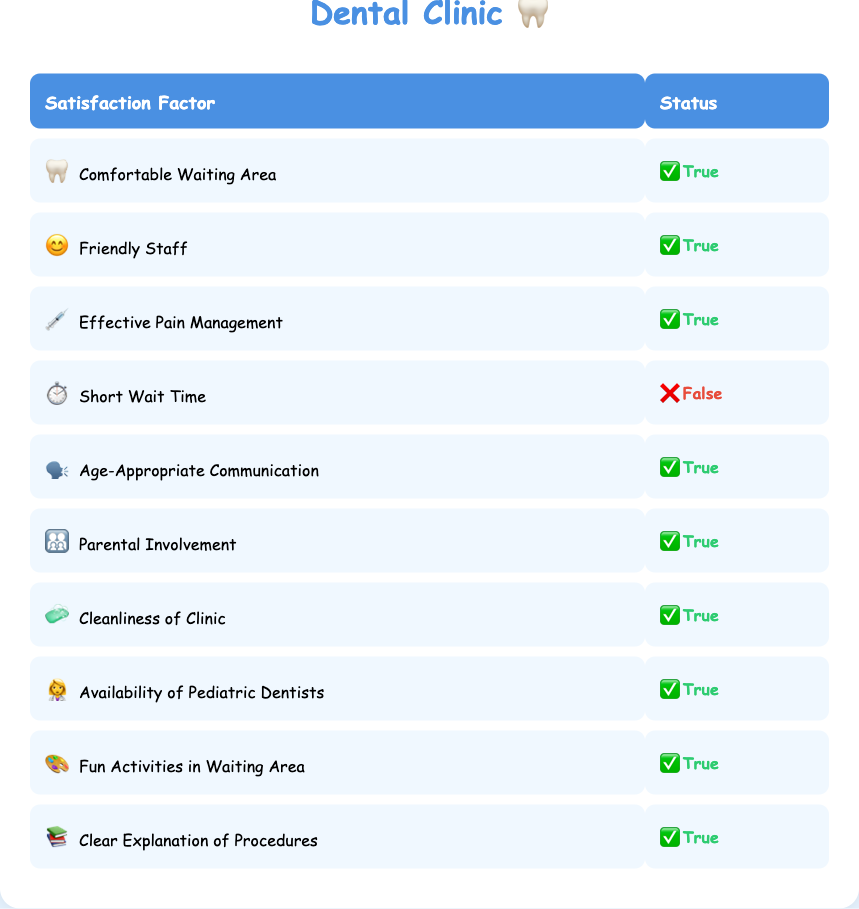What factors contribute to patient satisfaction in the clinic? The table lists all factors contributing to patient satisfaction, which are: Comfortable Waiting Area, Friendly Staff, Effective Pain Management, Age-Appropriate Communication, Parental Involvement, Cleanliness of Clinic, Availability of Pediatric Dentists, Fun Activities in Waiting Area, and Clear Explanation of Procedures. All factors except for Short Wait Time are marked as true.
Answer: Nine factors Is "Short Wait Time" a factor improving patient satisfaction? According to the table, "Short Wait Time" has a value of false, indicating it is not a factor that contributes to improving patient satisfaction.
Answer: No How many factors are rated positively (true) in the table? Counting the positively rated factors (true), we find: Comfortable Waiting Area, Friendly Staff, Effective Pain Management, Age-Appropriate Communication, Parental Involvement, Cleanliness of Clinic, Availability of Pediatric Dentists, Fun Activities in Waiting Area, and Clear Explanation of Procedures, totaling 9 true factors out of 10 listed.
Answer: Nine factors Are the staff in the clinic described as friendly? The table indicates that "Friendly Staff" is rated true, confirming that the staff is friendly as per the satisfaction rating.
Answer: Yes What is the difference between the number of positive and negative factors in patient satisfaction? There are 9 positive factors (true) and 1 negative factor (false) in the table. The difference is calculated as 9 - 1 = 8.
Answer: Eight factors Is Cleanliness of Clinic considered an important factor for satisfaction? The table confirms that "Cleanliness of Clinic" is marked as true, which means it is regarded as an important factor for patient satisfaction.
Answer: Yes Which factors rated as true emphasize a child-friendly environment? The factors most relevant to a child-friendly environment that are rated true include: Comfortable Waiting Area, Friendly Staff, Fun Activities in Waiting Area, Age-Appropriate Communication, and Parental Involvement.
Answer: Five factors What is the ratio of positive to negative factors in patient satisfaction? There are 9 positive factors (true) and 1 negative factor (false) in the table. The ratio is calculated as 9/1, which simplifies to 9:1.
Answer: Nine to one Which single factor has the greatest potential to improve patient satisfaction? Since all factors except for "Short Wait Time" are rated true, while "Short Wait Time" is false, the remaining factors could together provide significant improvement. However, none of the single factors from those rated true stands out above the rest based solely on this context.
Answer: Cannot be determined 